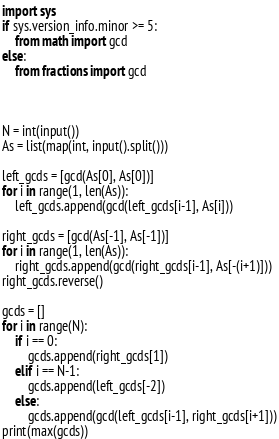<code> <loc_0><loc_0><loc_500><loc_500><_Python_>import sys
if sys.version_info.minor >= 5:
    from math import gcd
else:
    from fractions import gcd



N = int(input())
As = list(map(int, input().split()))

left_gcds = [gcd(As[0], As[0])]
for i in range(1, len(As)):
    left_gcds.append(gcd(left_gcds[i-1], As[i]))

right_gcds = [gcd(As[-1], As[-1])]
for i in range(1, len(As)):
    right_gcds.append(gcd(right_gcds[i-1], As[-(i+1)]))
right_gcds.reverse()

gcds = []
for i in range(N):
    if i == 0:
        gcds.append(right_gcds[1])
    elif i == N-1:
        gcds.append(left_gcds[-2])
    else:
        gcds.append(gcd(left_gcds[i-1], right_gcds[i+1]))
print(max(gcds))</code> 